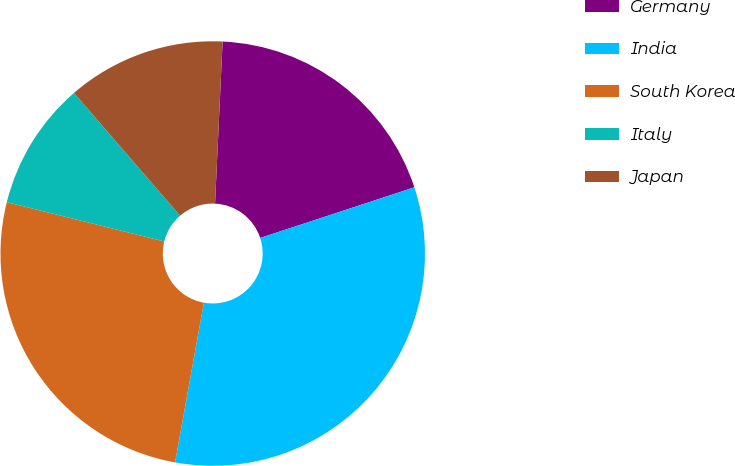Convert chart to OTSL. <chart><loc_0><loc_0><loc_500><loc_500><pie_chart><fcel>Germany<fcel>India<fcel>South Korea<fcel>Italy<fcel>Japan<nl><fcel>19.21%<fcel>32.89%<fcel>26.05%<fcel>9.77%<fcel>12.08%<nl></chart> 